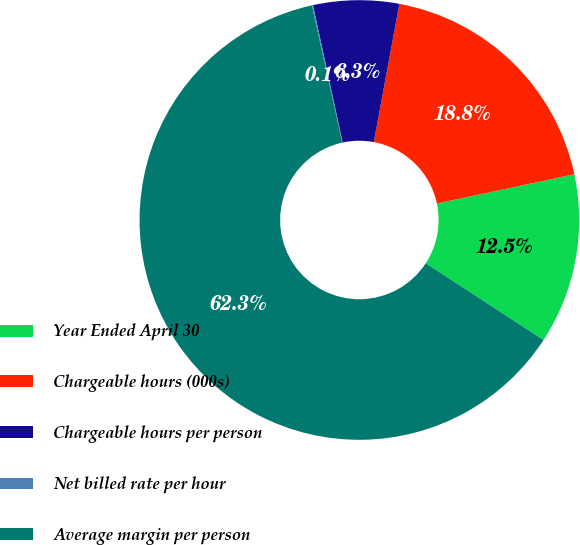Convert chart to OTSL. <chart><loc_0><loc_0><loc_500><loc_500><pie_chart><fcel>Year Ended April 30<fcel>Chargeable hours (000s)<fcel>Chargeable hours per person<fcel>Net billed rate per hour<fcel>Average margin per person<nl><fcel>12.53%<fcel>18.75%<fcel>6.3%<fcel>0.08%<fcel>62.34%<nl></chart> 